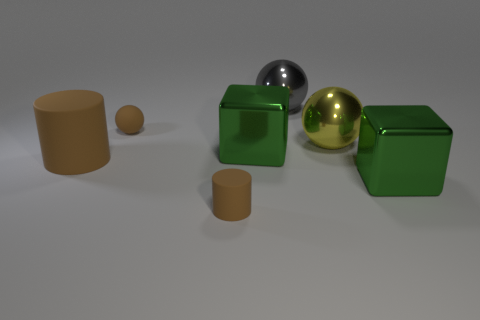Subtract all small brown spheres. How many spheres are left? 2 Subtract 1 spheres. How many spheres are left? 2 Subtract all cyan spheres. Subtract all yellow cylinders. How many spheres are left? 3 Add 3 big gray shiny cubes. How many objects exist? 10 Subtract 1 gray spheres. How many objects are left? 6 Subtract all blocks. How many objects are left? 5 Subtract all yellow balls. Subtract all large gray metallic spheres. How many objects are left? 5 Add 2 matte balls. How many matte balls are left? 3 Add 1 small blue metallic objects. How many small blue metallic objects exist? 1 